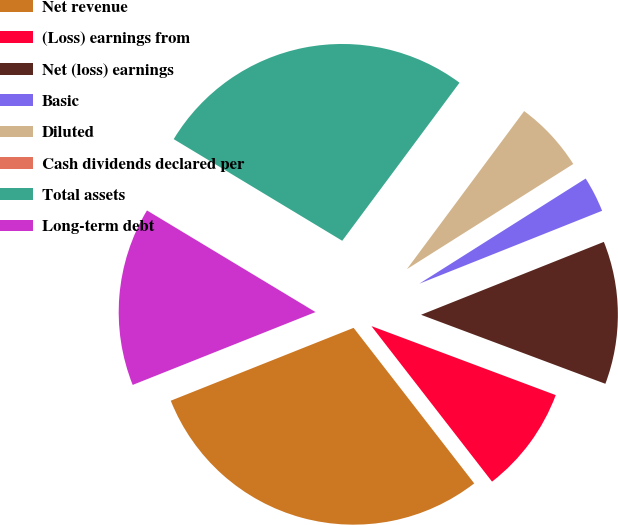Convert chart to OTSL. <chart><loc_0><loc_0><loc_500><loc_500><pie_chart><fcel>Net revenue<fcel>(Loss) earnings from<fcel>Net (loss) earnings<fcel>Basic<fcel>Diluted<fcel>Cash dividends declared per<fcel>Total assets<fcel>Long-term debt<nl><fcel>29.46%<fcel>8.8%<fcel>11.74%<fcel>2.93%<fcel>5.87%<fcel>0.0%<fcel>26.52%<fcel>14.67%<nl></chart> 